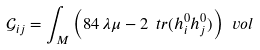<formula> <loc_0><loc_0><loc_500><loc_500>\mathcal { G } _ { i j } = \int _ { M } \left ( 8 4 \, \lambda \mu - 2 \ t r ( h ^ { 0 } _ { i } h ^ { 0 } _ { j } ) \right ) \ v o l</formula> 